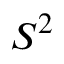Convert formula to latex. <formula><loc_0><loc_0><loc_500><loc_500>S ^ { 2 }</formula> 